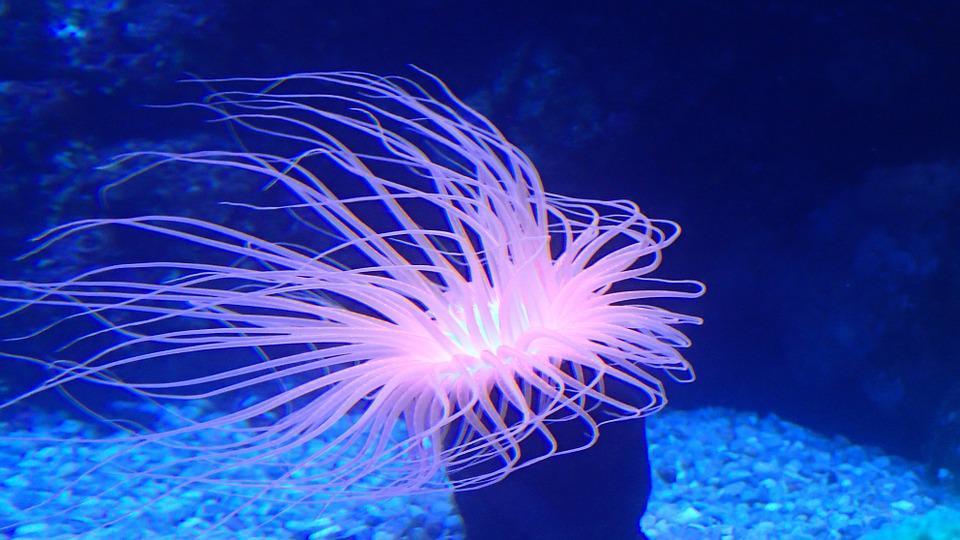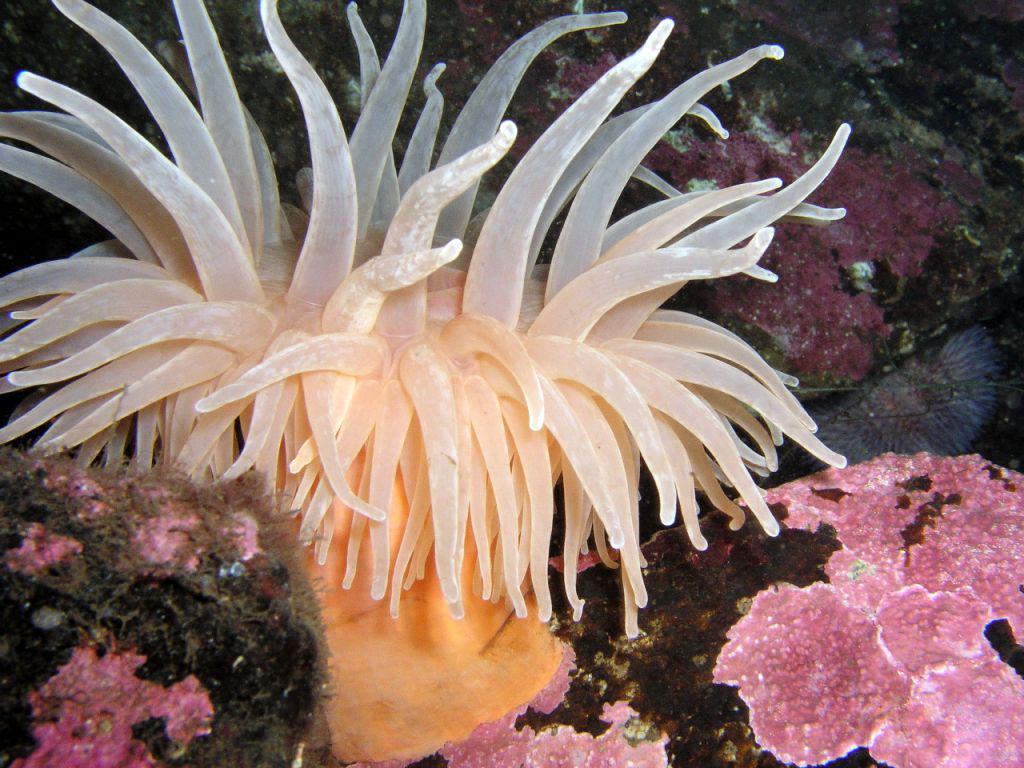The first image is the image on the left, the second image is the image on the right. Assess this claim about the two images: "An anemone image includes a black-and-white almost zebra-like pattern.". Correct or not? Answer yes or no. No. The first image is the image on the left, the second image is the image on the right. Assess this claim about the two images: "The anemones in the image on the left have black and white trunks". Correct or not? Answer yes or no. No. 